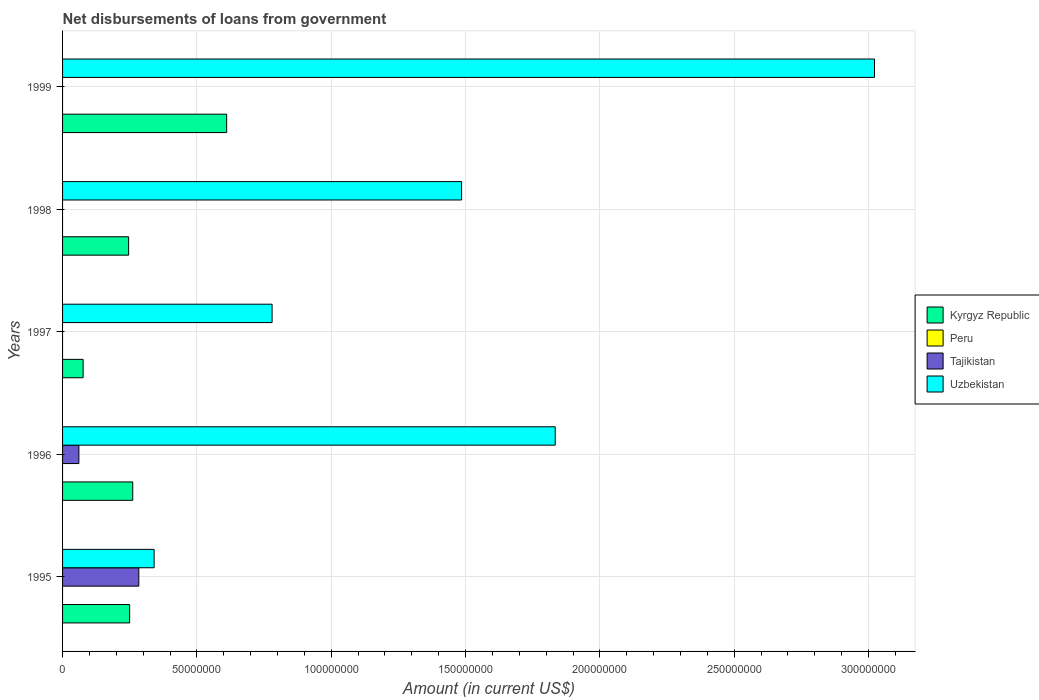How many different coloured bars are there?
Your response must be concise. 3. How many groups of bars are there?
Your response must be concise. 5. Are the number of bars on each tick of the Y-axis equal?
Make the answer very short. No. How many bars are there on the 2nd tick from the top?
Provide a succinct answer. 2. In how many cases, is the number of bars for a given year not equal to the number of legend labels?
Provide a succinct answer. 5. Across all years, what is the maximum amount of loan disbursed from government in Tajikistan?
Your answer should be compact. 2.84e+07. Across all years, what is the minimum amount of loan disbursed from government in Kyrgyz Republic?
Give a very brief answer. 7.65e+06. In which year was the amount of loan disbursed from government in Tajikistan maximum?
Provide a succinct answer. 1995. What is the total amount of loan disbursed from government in Tajikistan in the graph?
Offer a terse response. 3.45e+07. What is the difference between the amount of loan disbursed from government in Kyrgyz Republic in 1995 and that in 1998?
Make the answer very short. 3.77e+05. What is the difference between the amount of loan disbursed from government in Kyrgyz Republic in 1998 and the amount of loan disbursed from government in Tajikistan in 1997?
Offer a very short reply. 2.46e+07. What is the average amount of loan disbursed from government in Tajikistan per year?
Give a very brief answer. 6.89e+06. In the year 1998, what is the difference between the amount of loan disbursed from government in Kyrgyz Republic and amount of loan disbursed from government in Uzbekistan?
Offer a very short reply. -1.24e+08. In how many years, is the amount of loan disbursed from government in Uzbekistan greater than 60000000 US$?
Provide a short and direct response. 4. What is the ratio of the amount of loan disbursed from government in Uzbekistan in 1995 to that in 1997?
Offer a very short reply. 0.44. What is the difference between the highest and the second highest amount of loan disbursed from government in Uzbekistan?
Give a very brief answer. 1.19e+08. What is the difference between the highest and the lowest amount of loan disbursed from government in Tajikistan?
Offer a terse response. 2.84e+07. How many bars are there?
Provide a short and direct response. 12. Are all the bars in the graph horizontal?
Your answer should be very brief. Yes. Are the values on the major ticks of X-axis written in scientific E-notation?
Your response must be concise. No. Does the graph contain grids?
Your response must be concise. Yes. Where does the legend appear in the graph?
Offer a very short reply. Center right. How many legend labels are there?
Ensure brevity in your answer.  4. What is the title of the graph?
Offer a terse response. Net disbursements of loans from government. What is the label or title of the X-axis?
Your answer should be very brief. Amount (in current US$). What is the Amount (in current US$) of Kyrgyz Republic in 1995?
Provide a short and direct response. 2.50e+07. What is the Amount (in current US$) in Tajikistan in 1995?
Keep it short and to the point. 2.84e+07. What is the Amount (in current US$) in Uzbekistan in 1995?
Your answer should be very brief. 3.41e+07. What is the Amount (in current US$) of Kyrgyz Republic in 1996?
Give a very brief answer. 2.61e+07. What is the Amount (in current US$) in Peru in 1996?
Offer a terse response. 0. What is the Amount (in current US$) of Tajikistan in 1996?
Provide a short and direct response. 6.08e+06. What is the Amount (in current US$) of Uzbekistan in 1996?
Your answer should be compact. 1.83e+08. What is the Amount (in current US$) of Kyrgyz Republic in 1997?
Offer a very short reply. 7.65e+06. What is the Amount (in current US$) of Uzbekistan in 1997?
Offer a very short reply. 7.80e+07. What is the Amount (in current US$) in Kyrgyz Republic in 1998?
Provide a short and direct response. 2.46e+07. What is the Amount (in current US$) of Peru in 1998?
Your response must be concise. 0. What is the Amount (in current US$) of Uzbekistan in 1998?
Your answer should be compact. 1.49e+08. What is the Amount (in current US$) of Kyrgyz Republic in 1999?
Your response must be concise. 6.11e+07. What is the Amount (in current US$) in Tajikistan in 1999?
Provide a short and direct response. 0. What is the Amount (in current US$) in Uzbekistan in 1999?
Your response must be concise. 3.02e+08. Across all years, what is the maximum Amount (in current US$) of Kyrgyz Republic?
Offer a terse response. 6.11e+07. Across all years, what is the maximum Amount (in current US$) of Tajikistan?
Keep it short and to the point. 2.84e+07. Across all years, what is the maximum Amount (in current US$) of Uzbekistan?
Provide a succinct answer. 3.02e+08. Across all years, what is the minimum Amount (in current US$) in Kyrgyz Republic?
Keep it short and to the point. 7.65e+06. Across all years, what is the minimum Amount (in current US$) in Uzbekistan?
Provide a succinct answer. 3.41e+07. What is the total Amount (in current US$) in Kyrgyz Republic in the graph?
Provide a short and direct response. 1.44e+08. What is the total Amount (in current US$) of Tajikistan in the graph?
Your answer should be very brief. 3.45e+07. What is the total Amount (in current US$) of Uzbekistan in the graph?
Make the answer very short. 7.46e+08. What is the difference between the Amount (in current US$) in Kyrgyz Republic in 1995 and that in 1996?
Make the answer very short. -1.16e+06. What is the difference between the Amount (in current US$) in Tajikistan in 1995 and that in 1996?
Your answer should be very brief. 2.23e+07. What is the difference between the Amount (in current US$) of Uzbekistan in 1995 and that in 1996?
Provide a succinct answer. -1.49e+08. What is the difference between the Amount (in current US$) in Kyrgyz Republic in 1995 and that in 1997?
Offer a very short reply. 1.73e+07. What is the difference between the Amount (in current US$) in Uzbekistan in 1995 and that in 1997?
Provide a short and direct response. -4.39e+07. What is the difference between the Amount (in current US$) in Kyrgyz Republic in 1995 and that in 1998?
Offer a terse response. 3.77e+05. What is the difference between the Amount (in current US$) of Uzbekistan in 1995 and that in 1998?
Provide a short and direct response. -1.14e+08. What is the difference between the Amount (in current US$) in Kyrgyz Republic in 1995 and that in 1999?
Give a very brief answer. -3.61e+07. What is the difference between the Amount (in current US$) in Uzbekistan in 1995 and that in 1999?
Provide a succinct answer. -2.68e+08. What is the difference between the Amount (in current US$) in Kyrgyz Republic in 1996 and that in 1997?
Ensure brevity in your answer.  1.85e+07. What is the difference between the Amount (in current US$) of Uzbekistan in 1996 and that in 1997?
Your response must be concise. 1.05e+08. What is the difference between the Amount (in current US$) of Kyrgyz Republic in 1996 and that in 1998?
Your answer should be compact. 1.54e+06. What is the difference between the Amount (in current US$) in Uzbekistan in 1996 and that in 1998?
Offer a very short reply. 3.48e+07. What is the difference between the Amount (in current US$) in Kyrgyz Republic in 1996 and that in 1999?
Make the answer very short. -3.50e+07. What is the difference between the Amount (in current US$) in Uzbekistan in 1996 and that in 1999?
Give a very brief answer. -1.19e+08. What is the difference between the Amount (in current US$) of Kyrgyz Republic in 1997 and that in 1998?
Keep it short and to the point. -1.69e+07. What is the difference between the Amount (in current US$) in Uzbekistan in 1997 and that in 1998?
Ensure brevity in your answer.  -7.05e+07. What is the difference between the Amount (in current US$) of Kyrgyz Republic in 1997 and that in 1999?
Offer a very short reply. -5.34e+07. What is the difference between the Amount (in current US$) in Uzbekistan in 1997 and that in 1999?
Keep it short and to the point. -2.24e+08. What is the difference between the Amount (in current US$) of Kyrgyz Republic in 1998 and that in 1999?
Ensure brevity in your answer.  -3.65e+07. What is the difference between the Amount (in current US$) in Uzbekistan in 1998 and that in 1999?
Offer a very short reply. -1.54e+08. What is the difference between the Amount (in current US$) in Kyrgyz Republic in 1995 and the Amount (in current US$) in Tajikistan in 1996?
Give a very brief answer. 1.89e+07. What is the difference between the Amount (in current US$) in Kyrgyz Republic in 1995 and the Amount (in current US$) in Uzbekistan in 1996?
Your answer should be compact. -1.58e+08. What is the difference between the Amount (in current US$) of Tajikistan in 1995 and the Amount (in current US$) of Uzbekistan in 1996?
Offer a terse response. -1.55e+08. What is the difference between the Amount (in current US$) of Kyrgyz Republic in 1995 and the Amount (in current US$) of Uzbekistan in 1997?
Your answer should be very brief. -5.30e+07. What is the difference between the Amount (in current US$) of Tajikistan in 1995 and the Amount (in current US$) of Uzbekistan in 1997?
Offer a very short reply. -4.96e+07. What is the difference between the Amount (in current US$) of Kyrgyz Republic in 1995 and the Amount (in current US$) of Uzbekistan in 1998?
Make the answer very short. -1.24e+08. What is the difference between the Amount (in current US$) of Tajikistan in 1995 and the Amount (in current US$) of Uzbekistan in 1998?
Your response must be concise. -1.20e+08. What is the difference between the Amount (in current US$) of Kyrgyz Republic in 1995 and the Amount (in current US$) of Uzbekistan in 1999?
Your answer should be very brief. -2.77e+08. What is the difference between the Amount (in current US$) in Tajikistan in 1995 and the Amount (in current US$) in Uzbekistan in 1999?
Provide a short and direct response. -2.74e+08. What is the difference between the Amount (in current US$) in Kyrgyz Republic in 1996 and the Amount (in current US$) in Uzbekistan in 1997?
Provide a succinct answer. -5.19e+07. What is the difference between the Amount (in current US$) in Tajikistan in 1996 and the Amount (in current US$) in Uzbekistan in 1997?
Offer a terse response. -7.19e+07. What is the difference between the Amount (in current US$) of Kyrgyz Republic in 1996 and the Amount (in current US$) of Uzbekistan in 1998?
Your response must be concise. -1.22e+08. What is the difference between the Amount (in current US$) in Tajikistan in 1996 and the Amount (in current US$) in Uzbekistan in 1998?
Ensure brevity in your answer.  -1.42e+08. What is the difference between the Amount (in current US$) in Kyrgyz Republic in 1996 and the Amount (in current US$) in Uzbekistan in 1999?
Keep it short and to the point. -2.76e+08. What is the difference between the Amount (in current US$) of Tajikistan in 1996 and the Amount (in current US$) of Uzbekistan in 1999?
Offer a very short reply. -2.96e+08. What is the difference between the Amount (in current US$) in Kyrgyz Republic in 1997 and the Amount (in current US$) in Uzbekistan in 1998?
Make the answer very short. -1.41e+08. What is the difference between the Amount (in current US$) of Kyrgyz Republic in 1997 and the Amount (in current US$) of Uzbekistan in 1999?
Ensure brevity in your answer.  -2.95e+08. What is the difference between the Amount (in current US$) of Kyrgyz Republic in 1998 and the Amount (in current US$) of Uzbekistan in 1999?
Provide a succinct answer. -2.78e+08. What is the average Amount (in current US$) in Kyrgyz Republic per year?
Your answer should be very brief. 2.89e+07. What is the average Amount (in current US$) in Peru per year?
Keep it short and to the point. 0. What is the average Amount (in current US$) in Tajikistan per year?
Make the answer very short. 6.89e+06. What is the average Amount (in current US$) in Uzbekistan per year?
Your answer should be compact. 1.49e+08. In the year 1995, what is the difference between the Amount (in current US$) of Kyrgyz Republic and Amount (in current US$) of Tajikistan?
Ensure brevity in your answer.  -3.41e+06. In the year 1995, what is the difference between the Amount (in current US$) of Kyrgyz Republic and Amount (in current US$) of Uzbekistan?
Ensure brevity in your answer.  -9.11e+06. In the year 1995, what is the difference between the Amount (in current US$) in Tajikistan and Amount (in current US$) in Uzbekistan?
Offer a very short reply. -5.70e+06. In the year 1996, what is the difference between the Amount (in current US$) of Kyrgyz Republic and Amount (in current US$) of Tajikistan?
Keep it short and to the point. 2.00e+07. In the year 1996, what is the difference between the Amount (in current US$) in Kyrgyz Republic and Amount (in current US$) in Uzbekistan?
Provide a short and direct response. -1.57e+08. In the year 1996, what is the difference between the Amount (in current US$) of Tajikistan and Amount (in current US$) of Uzbekistan?
Make the answer very short. -1.77e+08. In the year 1997, what is the difference between the Amount (in current US$) in Kyrgyz Republic and Amount (in current US$) in Uzbekistan?
Provide a short and direct response. -7.03e+07. In the year 1998, what is the difference between the Amount (in current US$) in Kyrgyz Republic and Amount (in current US$) in Uzbekistan?
Give a very brief answer. -1.24e+08. In the year 1999, what is the difference between the Amount (in current US$) in Kyrgyz Republic and Amount (in current US$) in Uzbekistan?
Ensure brevity in your answer.  -2.41e+08. What is the ratio of the Amount (in current US$) in Kyrgyz Republic in 1995 to that in 1996?
Your answer should be compact. 0.96. What is the ratio of the Amount (in current US$) in Tajikistan in 1995 to that in 1996?
Offer a terse response. 4.67. What is the ratio of the Amount (in current US$) of Uzbekistan in 1995 to that in 1996?
Make the answer very short. 0.19. What is the ratio of the Amount (in current US$) of Kyrgyz Republic in 1995 to that in 1997?
Your response must be concise. 3.26. What is the ratio of the Amount (in current US$) in Uzbekistan in 1995 to that in 1997?
Give a very brief answer. 0.44. What is the ratio of the Amount (in current US$) of Kyrgyz Republic in 1995 to that in 1998?
Provide a short and direct response. 1.02. What is the ratio of the Amount (in current US$) in Uzbekistan in 1995 to that in 1998?
Your answer should be very brief. 0.23. What is the ratio of the Amount (in current US$) in Kyrgyz Republic in 1995 to that in 1999?
Provide a short and direct response. 0.41. What is the ratio of the Amount (in current US$) in Uzbekistan in 1995 to that in 1999?
Your answer should be compact. 0.11. What is the ratio of the Amount (in current US$) of Kyrgyz Republic in 1996 to that in 1997?
Your response must be concise. 3.41. What is the ratio of the Amount (in current US$) in Uzbekistan in 1996 to that in 1997?
Provide a succinct answer. 2.35. What is the ratio of the Amount (in current US$) of Kyrgyz Republic in 1996 to that in 1998?
Provide a short and direct response. 1.06. What is the ratio of the Amount (in current US$) of Uzbekistan in 1996 to that in 1998?
Your response must be concise. 1.23. What is the ratio of the Amount (in current US$) in Kyrgyz Republic in 1996 to that in 1999?
Provide a succinct answer. 0.43. What is the ratio of the Amount (in current US$) in Uzbekistan in 1996 to that in 1999?
Provide a short and direct response. 0.61. What is the ratio of the Amount (in current US$) of Kyrgyz Republic in 1997 to that in 1998?
Provide a short and direct response. 0.31. What is the ratio of the Amount (in current US$) in Uzbekistan in 1997 to that in 1998?
Ensure brevity in your answer.  0.53. What is the ratio of the Amount (in current US$) of Kyrgyz Republic in 1997 to that in 1999?
Ensure brevity in your answer.  0.13. What is the ratio of the Amount (in current US$) in Uzbekistan in 1997 to that in 1999?
Offer a terse response. 0.26. What is the ratio of the Amount (in current US$) in Kyrgyz Republic in 1998 to that in 1999?
Make the answer very short. 0.4. What is the ratio of the Amount (in current US$) in Uzbekistan in 1998 to that in 1999?
Your response must be concise. 0.49. What is the difference between the highest and the second highest Amount (in current US$) in Kyrgyz Republic?
Provide a short and direct response. 3.50e+07. What is the difference between the highest and the second highest Amount (in current US$) in Uzbekistan?
Keep it short and to the point. 1.19e+08. What is the difference between the highest and the lowest Amount (in current US$) in Kyrgyz Republic?
Provide a succinct answer. 5.34e+07. What is the difference between the highest and the lowest Amount (in current US$) of Tajikistan?
Keep it short and to the point. 2.84e+07. What is the difference between the highest and the lowest Amount (in current US$) in Uzbekistan?
Give a very brief answer. 2.68e+08. 